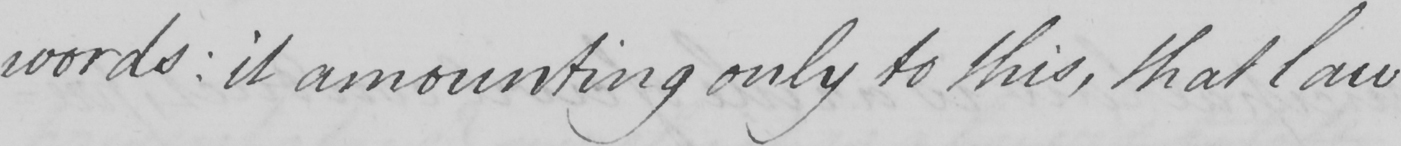Can you read and transcribe this handwriting? words: it amounting only to this, that law 